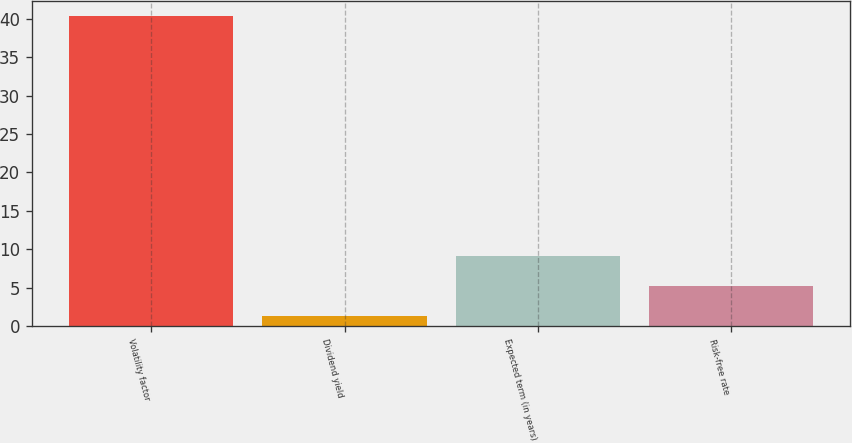Convert chart. <chart><loc_0><loc_0><loc_500><loc_500><bar_chart><fcel>Volatility factor<fcel>Dividend yield<fcel>Expected term (in years)<fcel>Risk-free rate<nl><fcel>40.3<fcel>1.3<fcel>9.1<fcel>5.2<nl></chart> 